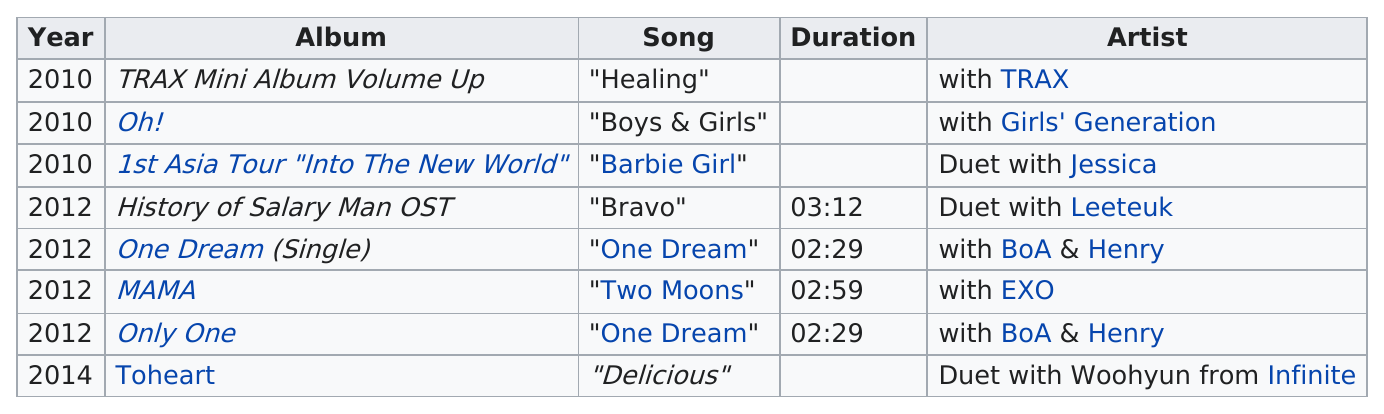Outline some significant characteristics in this image. Before 2014, the artist had released a total of 7 albums. Eight albums are listed in total. The most recent song on which they collaborated was 'Delicious'. Key has produced 5 albums since 2010. During the year 2010, there were a total of 3 collaborations that Key released. 